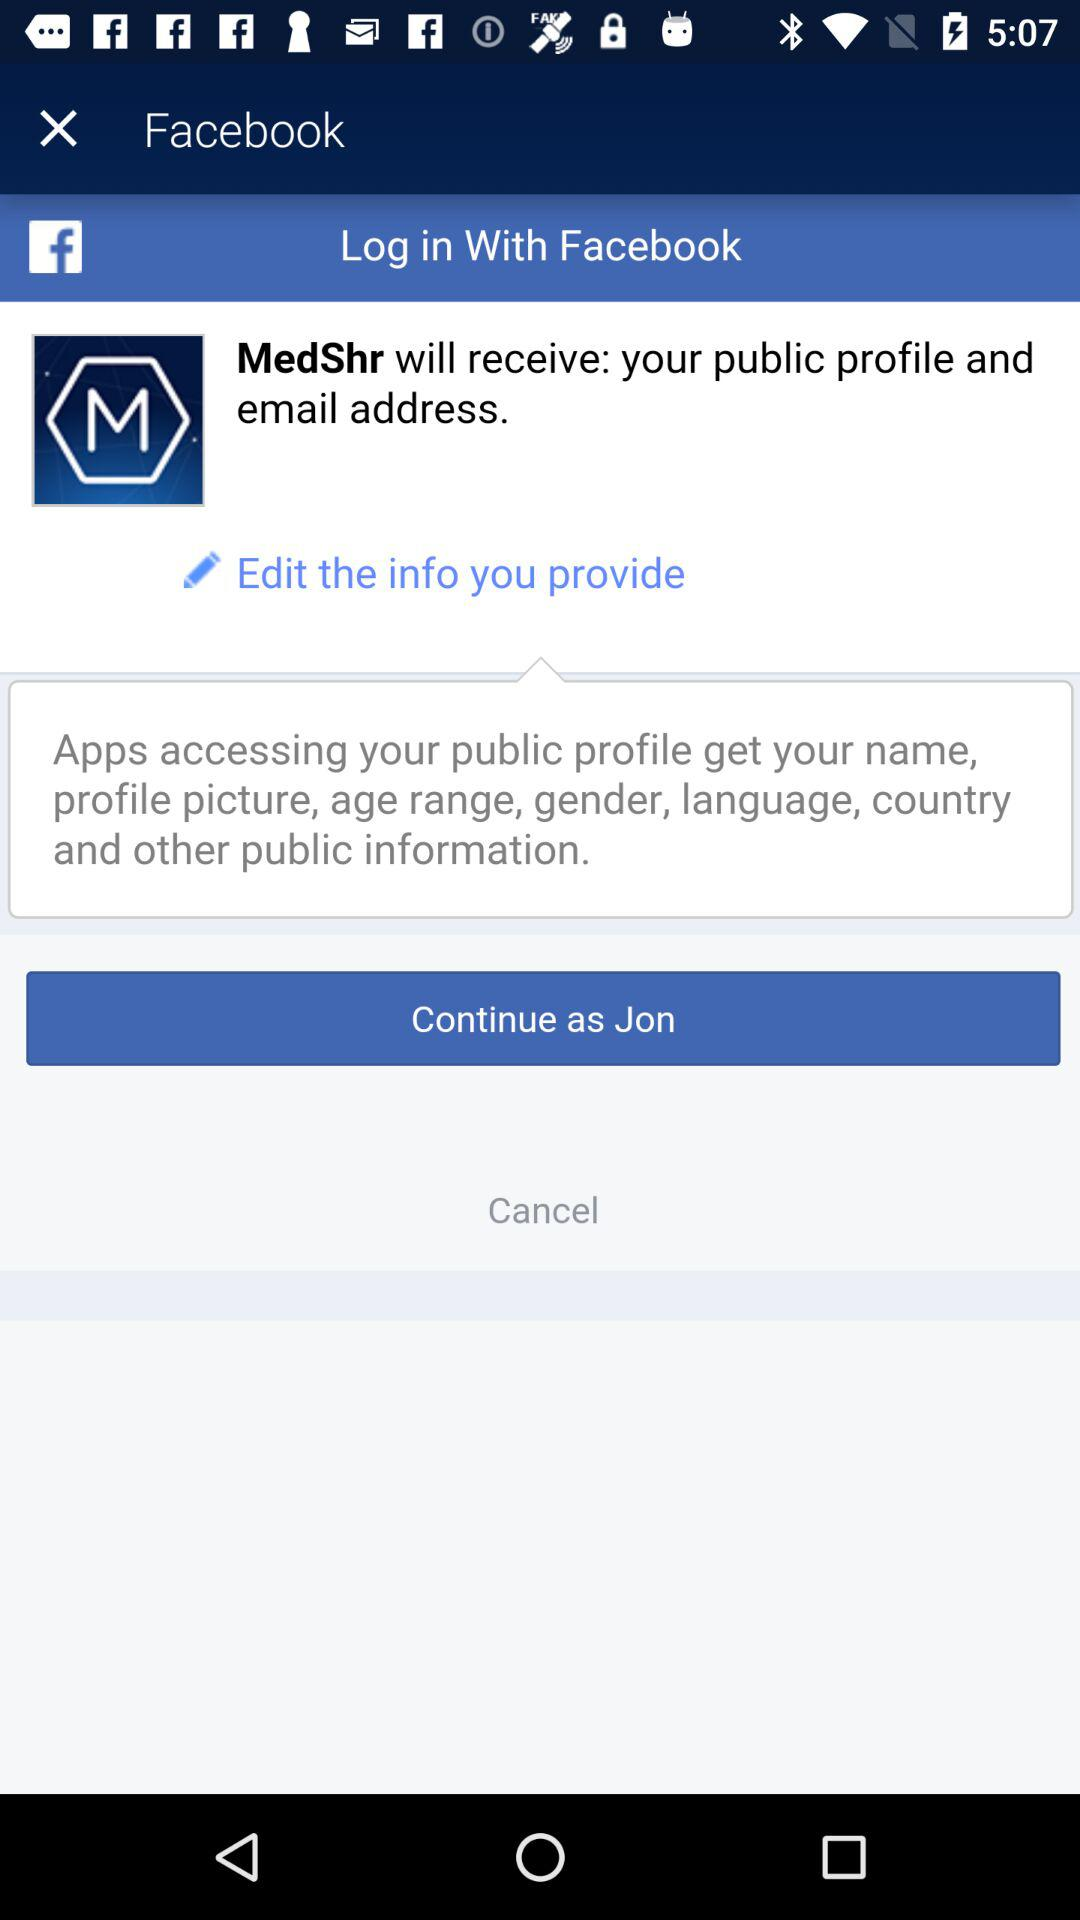By what account can we log in for the application? We can log in with Facebbok account. 